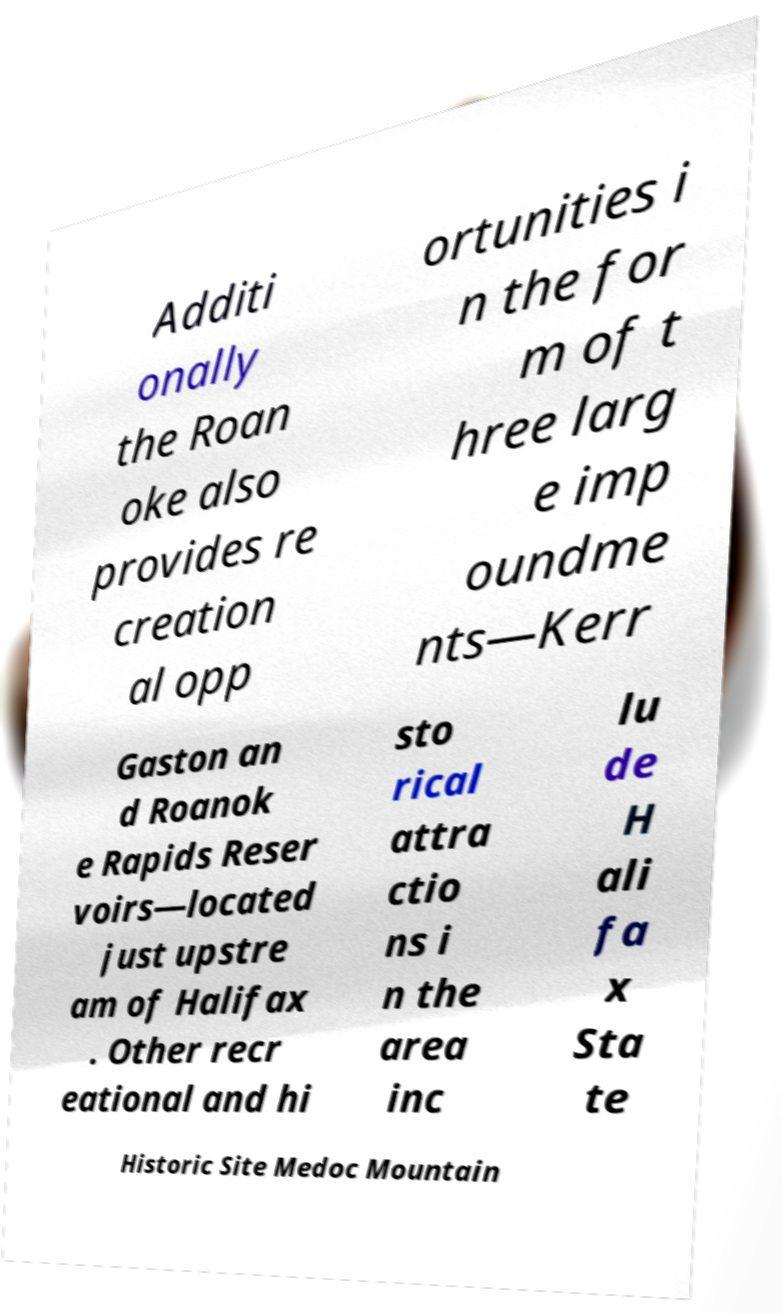There's text embedded in this image that I need extracted. Can you transcribe it verbatim? Additi onally the Roan oke also provides re creation al opp ortunities i n the for m of t hree larg e imp oundme nts—Kerr Gaston an d Roanok e Rapids Reser voirs—located just upstre am of Halifax . Other recr eational and hi sto rical attra ctio ns i n the area inc lu de H ali fa x Sta te Historic Site Medoc Mountain 